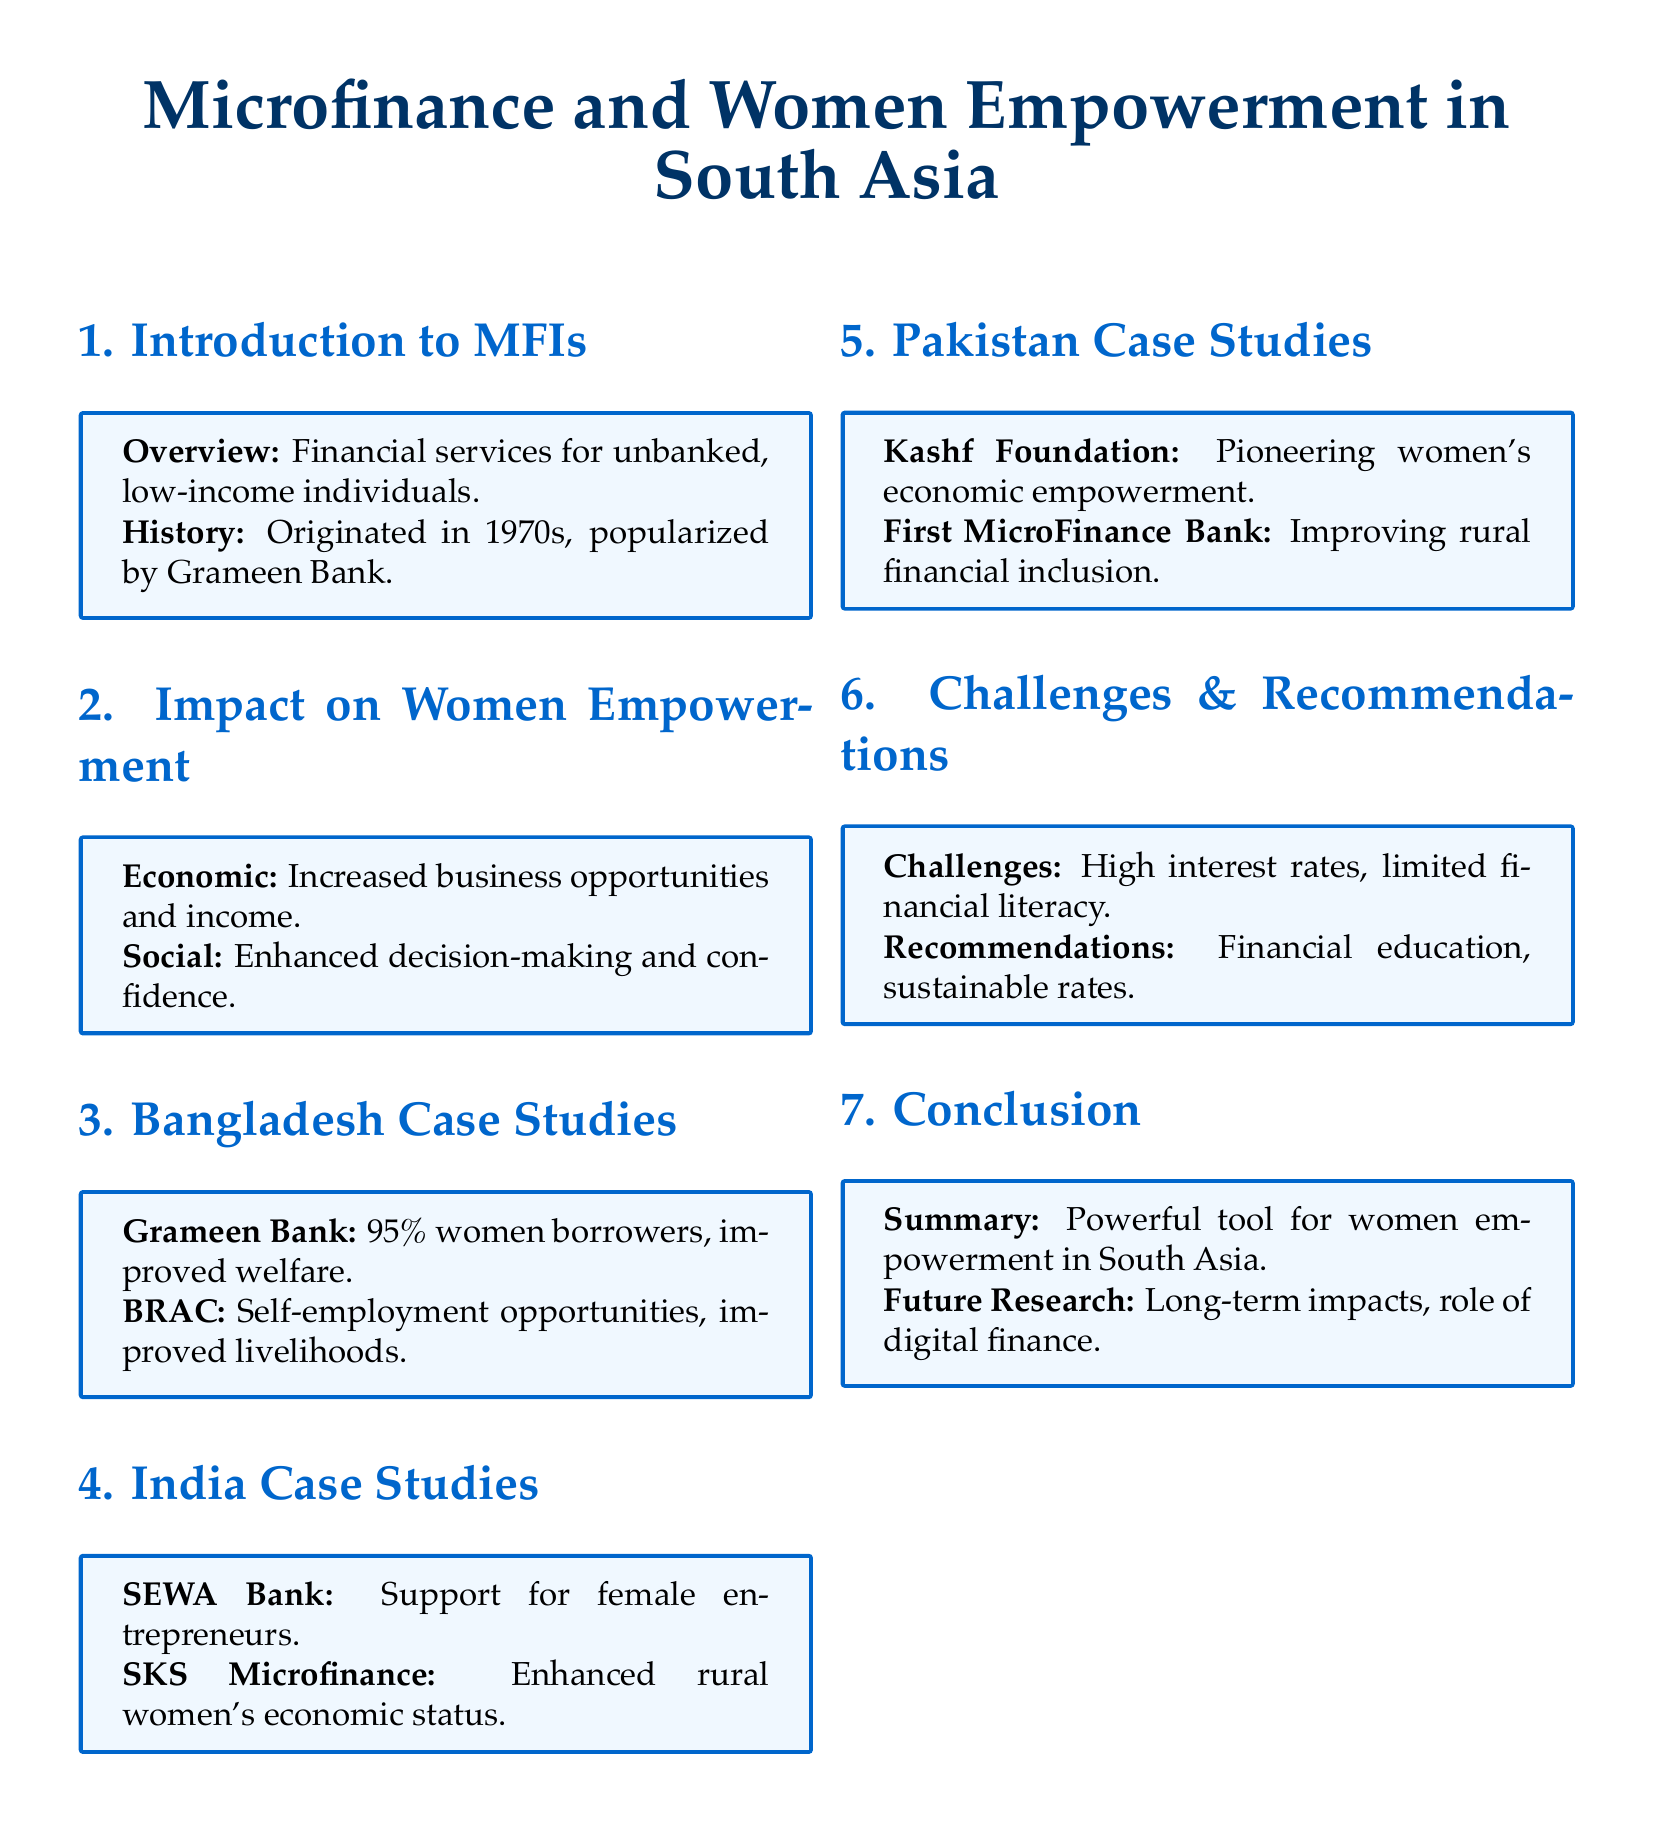What is the main focus of this document? The main focus is on the impact of microfinance institutions on women's empowerment in South Asia.
Answer: Impact of microfinance institutions on women's empowerment What percentage of Grameen Bank borrowers are women? The document states that 95% of borrowers from Grameen Bank are women.
Answer: 95% Which institution is noted for supporting female entrepreneurs in India? The SEWA Bank is identified as providing support for female entrepreneurs in India.
Answer: SEWA Bank What is one of the challenges mentioned regarding microfinance? One challenge noted is high interest rates associated with microfinance.
Answer: High interest rates What does the term "economic empowerment" relate to in the context of this document? Economic empowerment in this context relates to increased business opportunities and income for women.
Answer: Increased business opportunities and income Which foundation is pioneering women's economic empowerment in Pakistan? The Kashf Foundation is mentioned as pioneering women's economic empowerment in Pakistan.
Answer: Kashf Foundation What has been recommended to improve financial literacy? Financial education is recommended to enhance financial literacy among women.
Answer: Financial education What role is suggested for future research? Future research is suggested to explore the long-term impacts of microfinance and the role of digital finance.
Answer: Long-term impacts, role of digital finance 